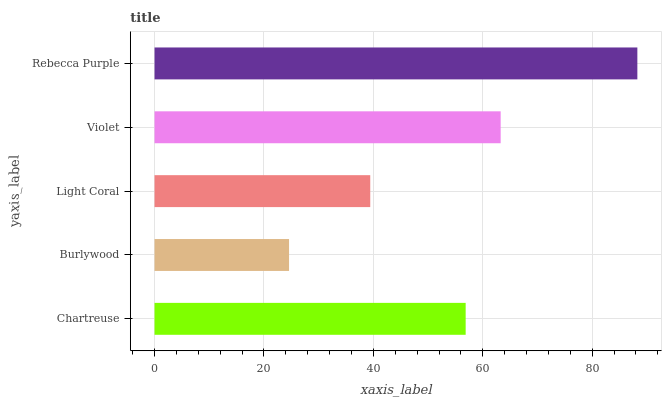Is Burlywood the minimum?
Answer yes or no. Yes. Is Rebecca Purple the maximum?
Answer yes or no. Yes. Is Light Coral the minimum?
Answer yes or no. No. Is Light Coral the maximum?
Answer yes or no. No. Is Light Coral greater than Burlywood?
Answer yes or no. Yes. Is Burlywood less than Light Coral?
Answer yes or no. Yes. Is Burlywood greater than Light Coral?
Answer yes or no. No. Is Light Coral less than Burlywood?
Answer yes or no. No. Is Chartreuse the high median?
Answer yes or no. Yes. Is Chartreuse the low median?
Answer yes or no. Yes. Is Rebecca Purple the high median?
Answer yes or no. No. Is Rebecca Purple the low median?
Answer yes or no. No. 